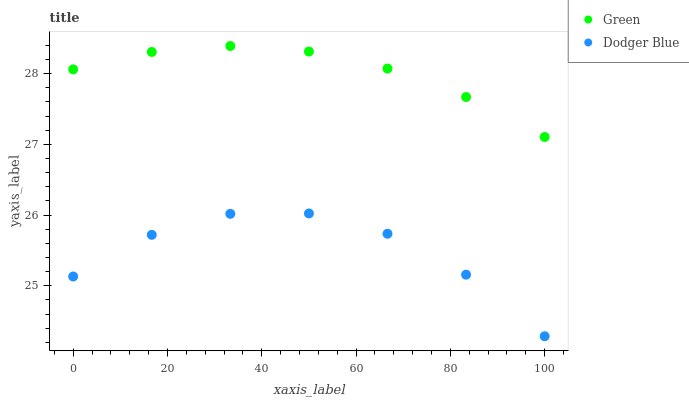Does Dodger Blue have the minimum area under the curve?
Answer yes or no. Yes. Does Green have the maximum area under the curve?
Answer yes or no. Yes. Does Green have the minimum area under the curve?
Answer yes or no. No. Is Green the smoothest?
Answer yes or no. Yes. Is Dodger Blue the roughest?
Answer yes or no. Yes. Is Green the roughest?
Answer yes or no. No. Does Dodger Blue have the lowest value?
Answer yes or no. Yes. Does Green have the lowest value?
Answer yes or no. No. Does Green have the highest value?
Answer yes or no. Yes. Is Dodger Blue less than Green?
Answer yes or no. Yes. Is Green greater than Dodger Blue?
Answer yes or no. Yes. Does Dodger Blue intersect Green?
Answer yes or no. No. 